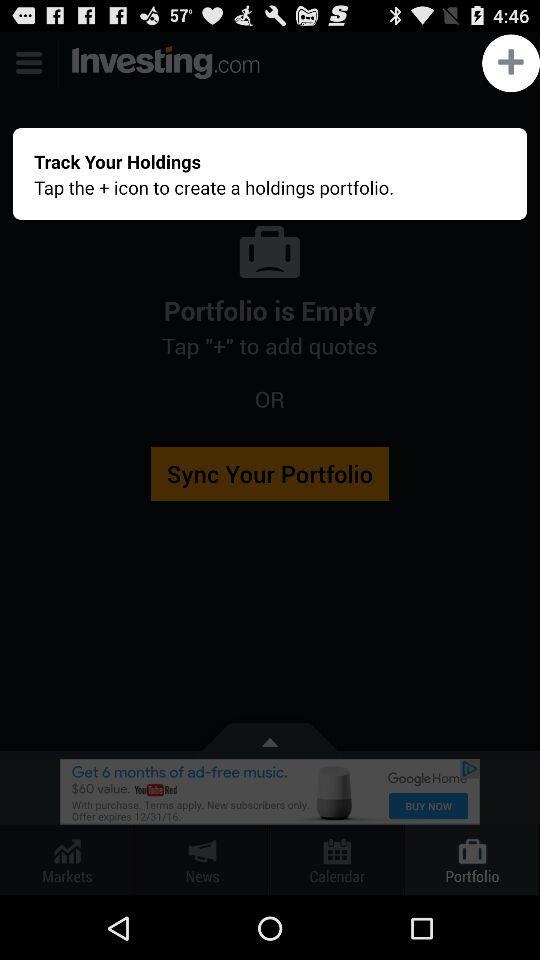What icon do we need to tap to create a holdings portfolio? We need to tap the + icon to create a holdings portfolio. 